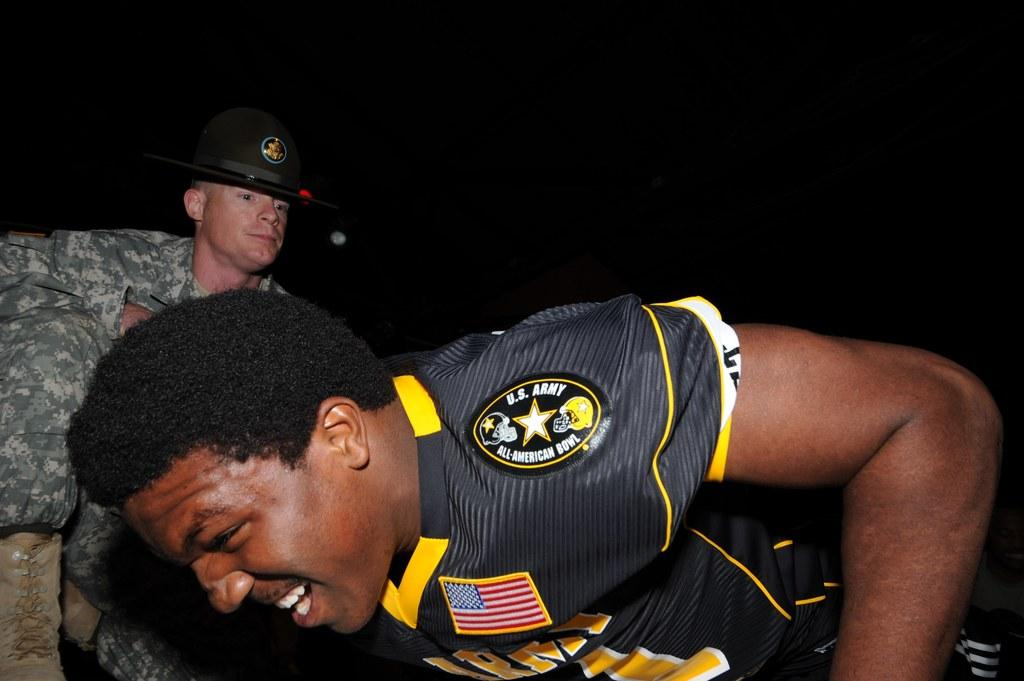<image>
Create a compact narrative representing the image presented. Football player for the US. Army works out while a drill instructor watches him. 